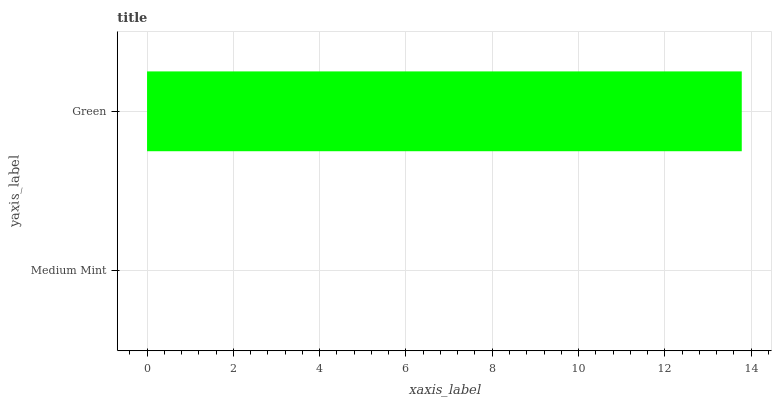Is Medium Mint the minimum?
Answer yes or no. Yes. Is Green the maximum?
Answer yes or no. Yes. Is Green the minimum?
Answer yes or no. No. Is Green greater than Medium Mint?
Answer yes or no. Yes. Is Medium Mint less than Green?
Answer yes or no. Yes. Is Medium Mint greater than Green?
Answer yes or no. No. Is Green less than Medium Mint?
Answer yes or no. No. Is Green the high median?
Answer yes or no. Yes. Is Medium Mint the low median?
Answer yes or no. Yes. Is Medium Mint the high median?
Answer yes or no. No. Is Green the low median?
Answer yes or no. No. 